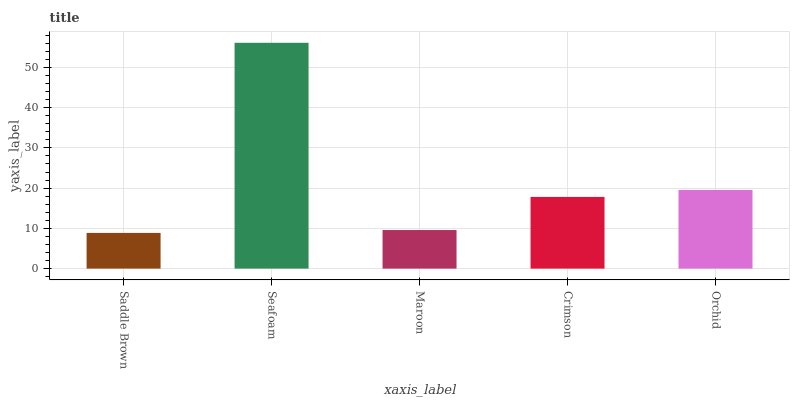Is Saddle Brown the minimum?
Answer yes or no. Yes. Is Seafoam the maximum?
Answer yes or no. Yes. Is Maroon the minimum?
Answer yes or no. No. Is Maroon the maximum?
Answer yes or no. No. Is Seafoam greater than Maroon?
Answer yes or no. Yes. Is Maroon less than Seafoam?
Answer yes or no. Yes. Is Maroon greater than Seafoam?
Answer yes or no. No. Is Seafoam less than Maroon?
Answer yes or no. No. Is Crimson the high median?
Answer yes or no. Yes. Is Crimson the low median?
Answer yes or no. Yes. Is Seafoam the high median?
Answer yes or no. No. Is Seafoam the low median?
Answer yes or no. No. 